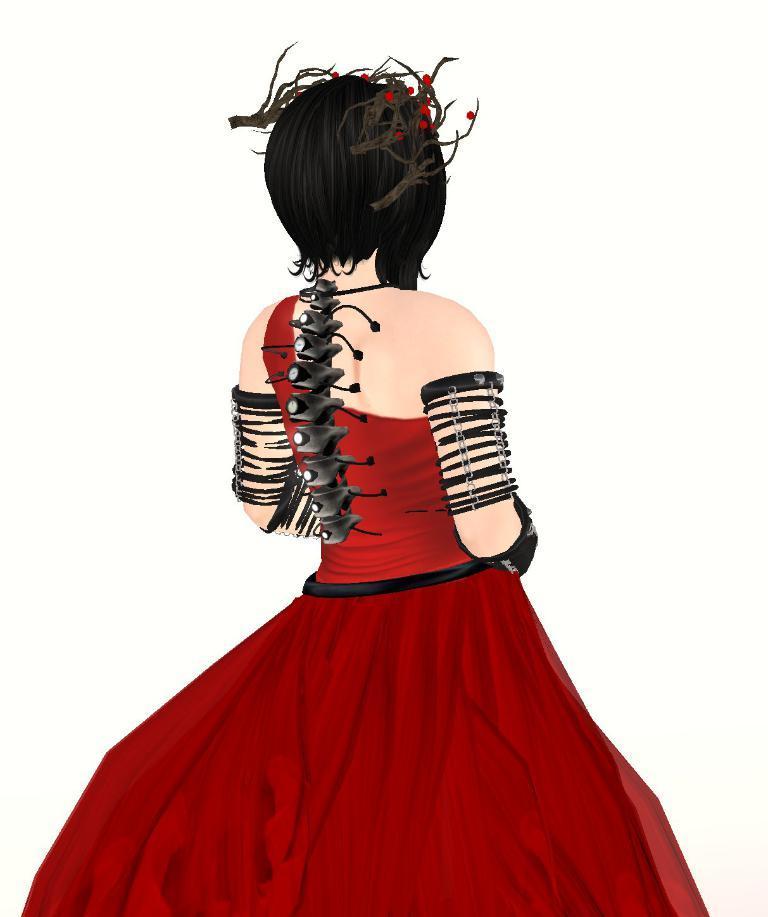Please provide a concise description of this image. In this image I can see the person wearing the dress and crown. I can see the dress is in red and black color. And there is a white background. 